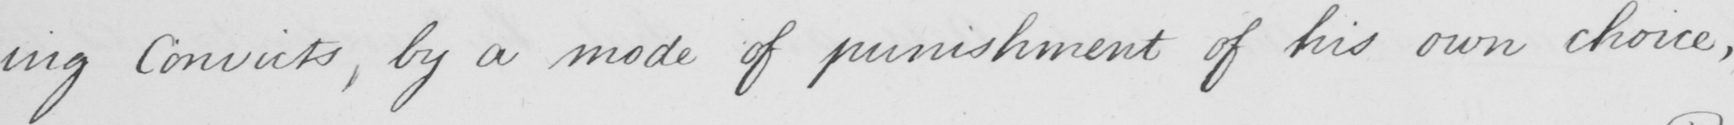What does this handwritten line say? -ing Convicts , by a mode of punishment of his own choice , 